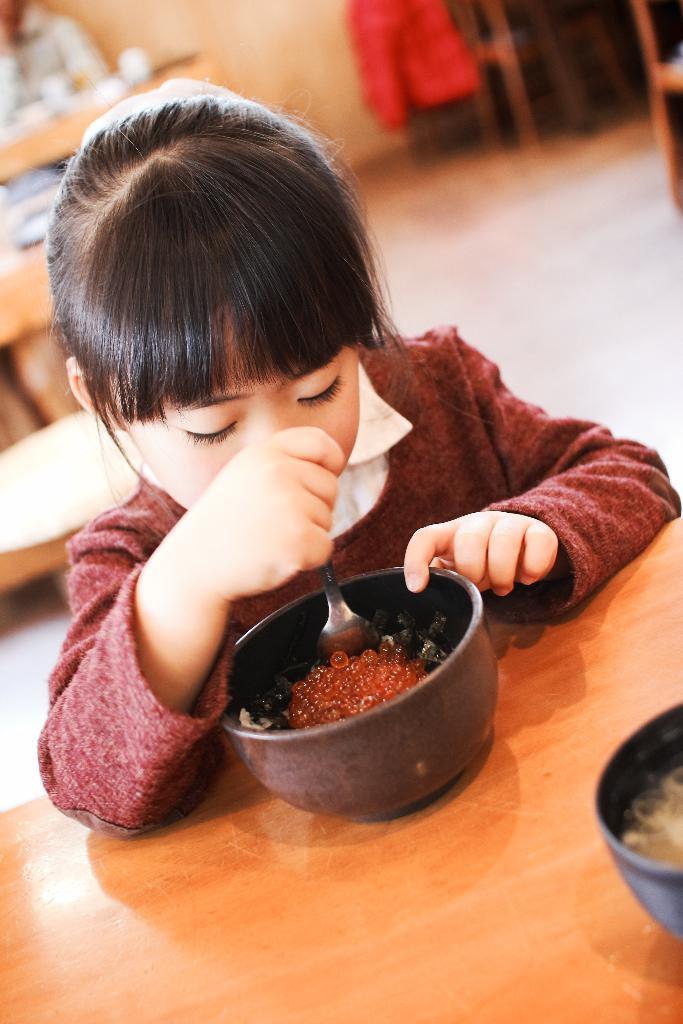Could you give a brief overview of what you see in this image? In this image in the front there is a girl eating food holding a spoon in her hand. In the background there tables and there is an object which is red in colour and there is a person sitting. In the front there is a bowl on the right side which is black in colour. 